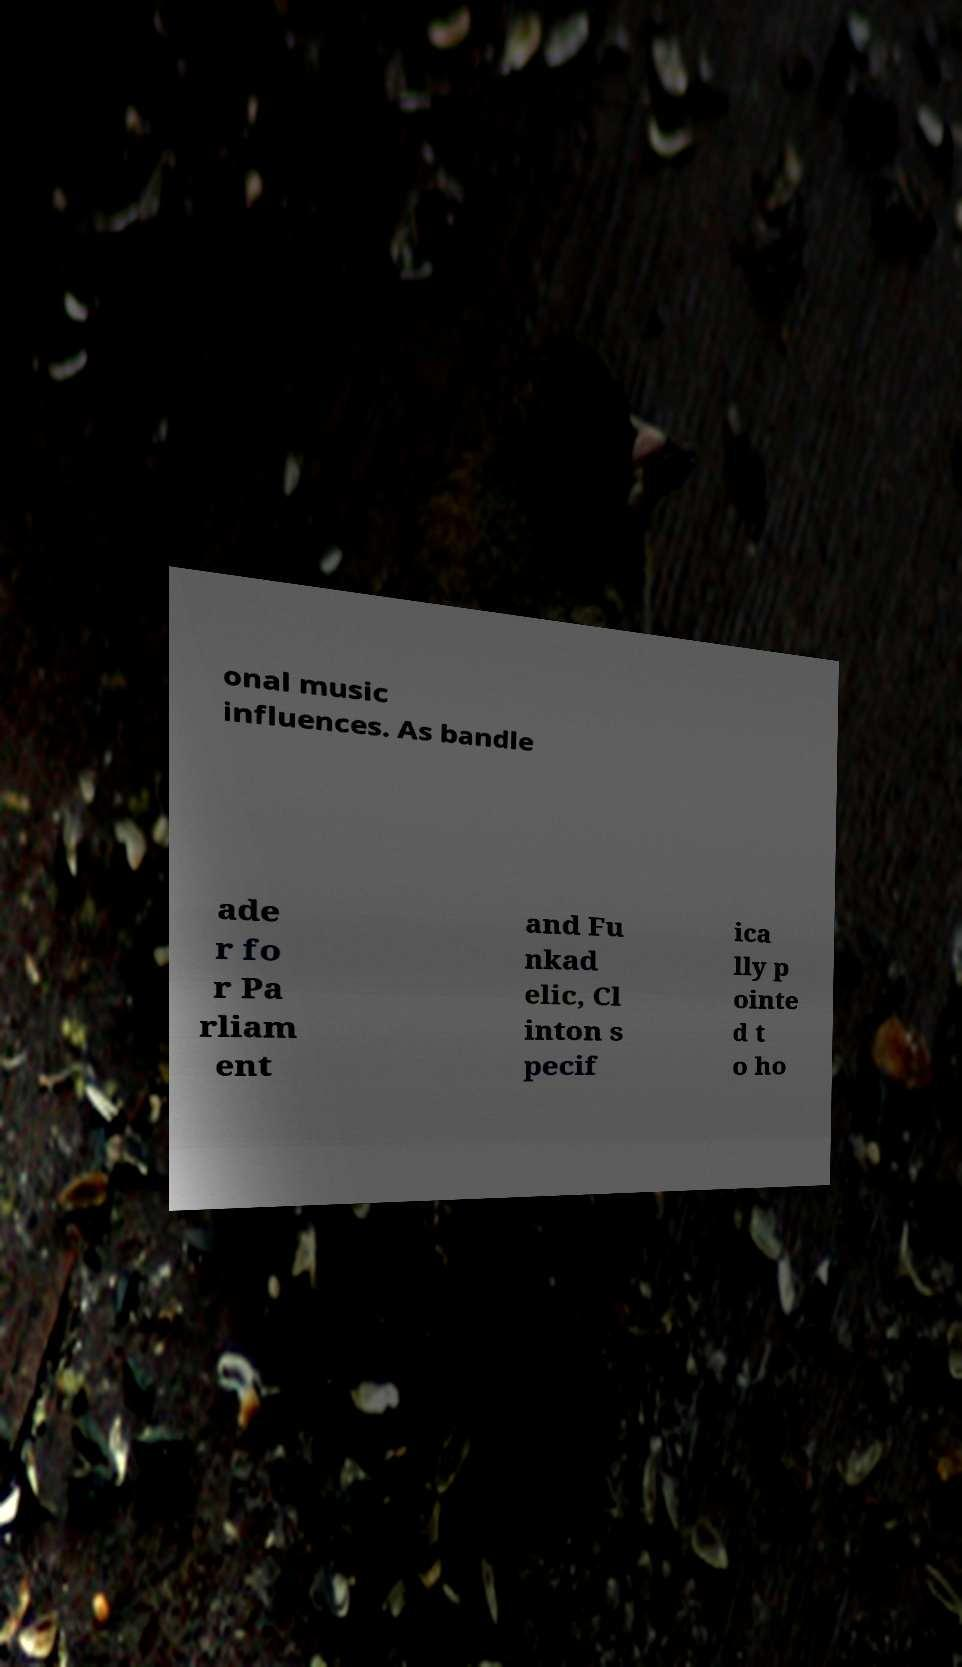For documentation purposes, I need the text within this image transcribed. Could you provide that? onal music influences. As bandle ade r fo r Pa rliam ent and Fu nkad elic, Cl inton s pecif ica lly p ointe d t o ho 